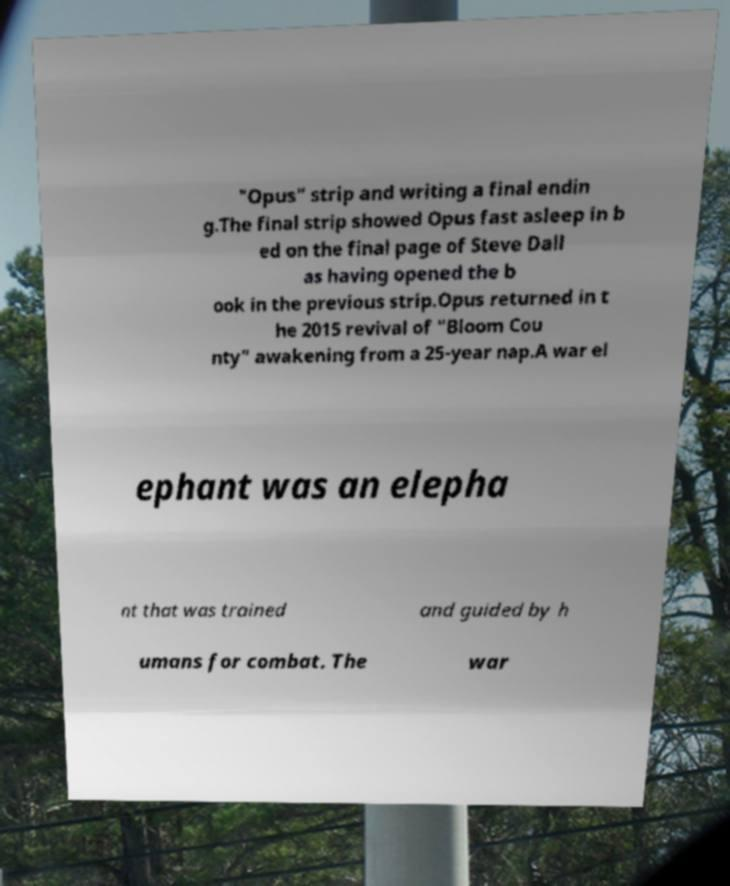Could you assist in decoding the text presented in this image and type it out clearly? "Opus" strip and writing a final endin g.The final strip showed Opus fast asleep in b ed on the final page of Steve Dall as having opened the b ook in the previous strip.Opus returned in t he 2015 revival of "Bloom Cou nty" awakening from a 25-year nap.A war el ephant was an elepha nt that was trained and guided by h umans for combat. The war 